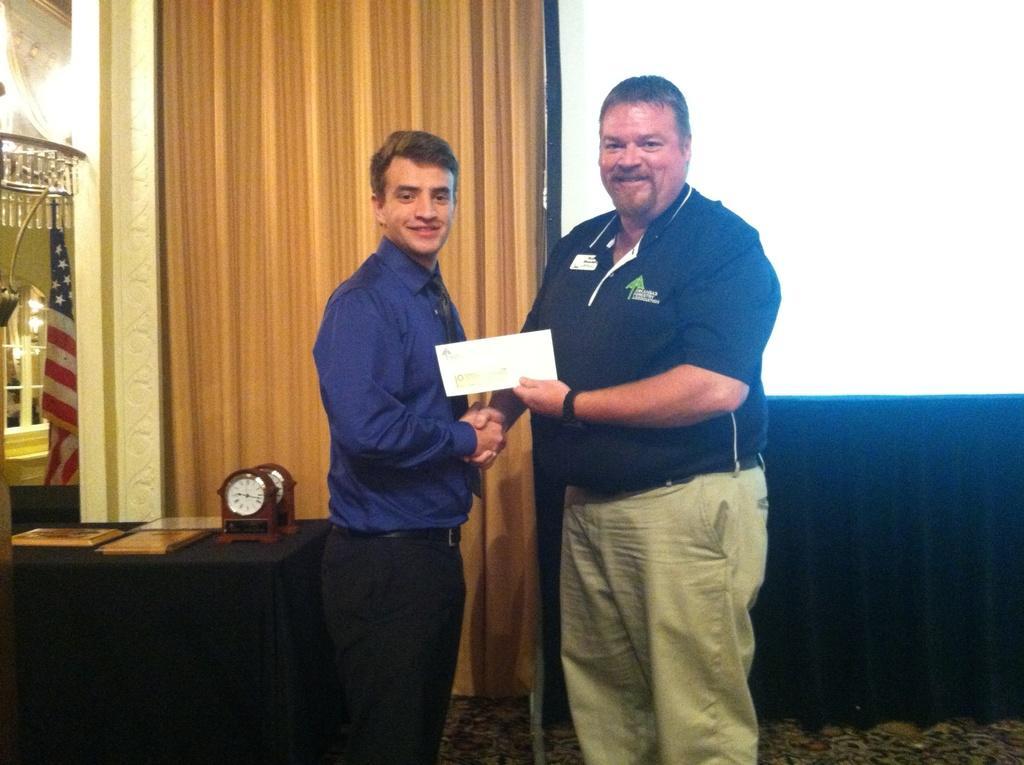How would you summarize this image in a sentence or two? In this image I can see two persons standing. The person at right wearing black shirt, brown pant and holding a paper, the person at left wearing blue shirt, black pant. Background I can see a flag and curtain in brown color. 